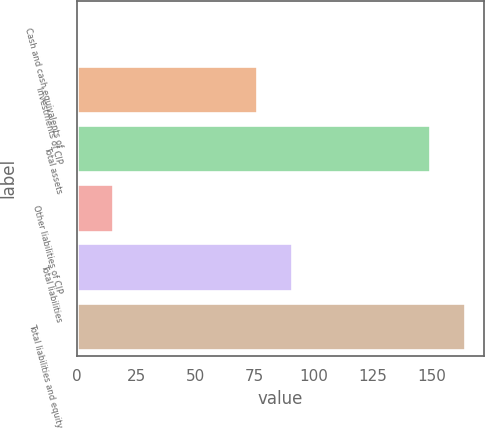Convert chart. <chart><loc_0><loc_0><loc_500><loc_500><bar_chart><fcel>Cash and cash equivalents of<fcel>Investments of CIP<fcel>Total assets<fcel>Other liabilities of CIP<fcel>Total liabilities<fcel>Total liabilities and equity<nl><fcel>0.4<fcel>76.2<fcel>149.2<fcel>15.28<fcel>91.08<fcel>164.08<nl></chart> 